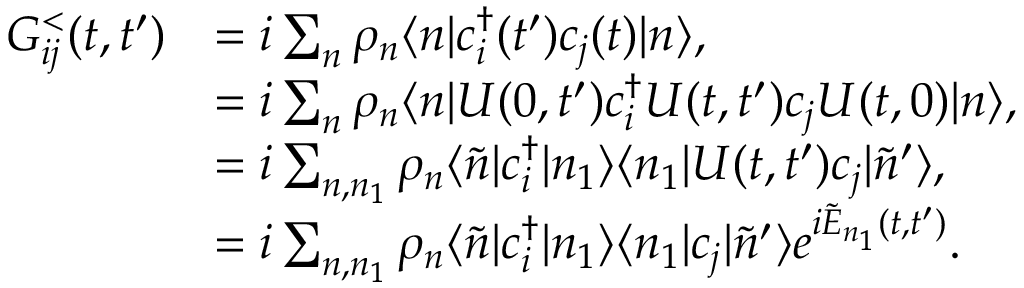Convert formula to latex. <formula><loc_0><loc_0><loc_500><loc_500>\begin{array} { r l } { G _ { i j } ^ { < } ( t , t ^ { \prime } ) } & { = i \sum _ { n } \rho _ { n } \langle n | c _ { i } ^ { \dagger } ( t ^ { \prime } ) c _ { j } ( t ) | n \rangle , } \\ & { = i \sum _ { n } \rho _ { n } \langle n | U ( 0 , t ^ { \prime } ) c _ { i } ^ { \dagger } U ( t , t ^ { \prime } ) c _ { j } U ( t , 0 ) | n \rangle , } \\ & { = i \sum _ { n , n _ { 1 } } \rho _ { n } \langle \tilde { n } | c _ { i } ^ { \dagger } | n _ { 1 } \rangle \langle n _ { 1 } | U ( t , t ^ { \prime } ) c _ { j } | \tilde { n } ^ { \prime } \rangle , } \\ & { = i \sum _ { n , n _ { 1 } } \rho _ { n } \langle \tilde { n } | c _ { i } ^ { \dagger } | n _ { 1 } \rangle \langle n _ { 1 } | c _ { j } | \tilde { n } ^ { \prime } \rangle e ^ { i \tilde { E } _ { n _ { 1 } } ( t , t ^ { \prime } ) } . } \end{array}</formula> 